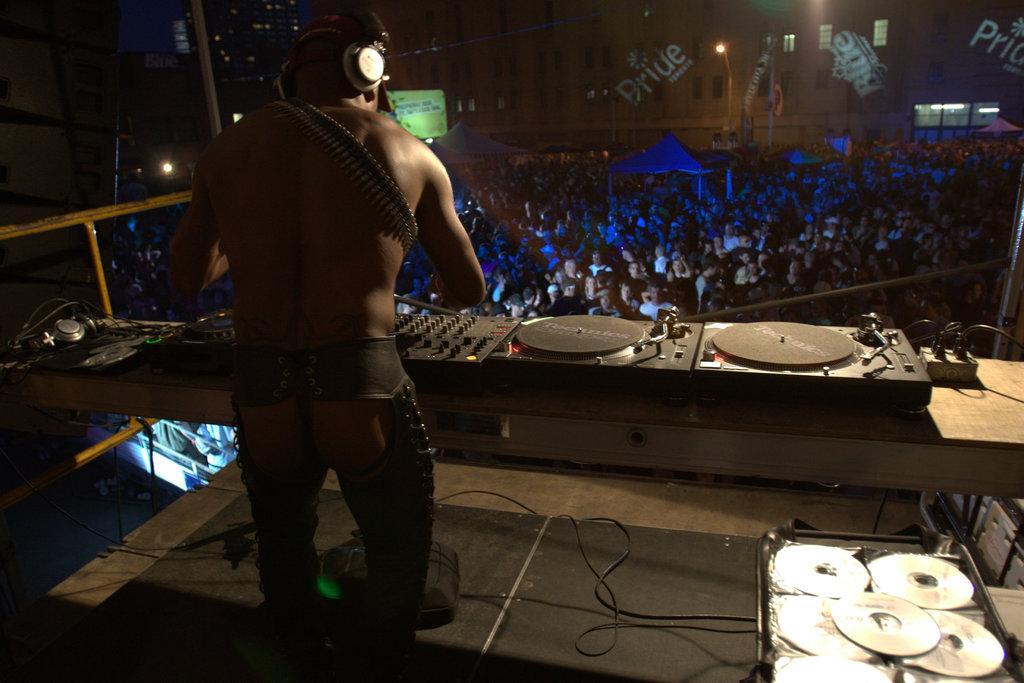In one or two sentences, can you explain what this image depicts? In this image there is a person standing. Before him there is a table having electrical devices and headset. Right bottom there is a table having compact discs. There are people on the floor having tents. Background there are buildings. Right side there is a street light. 